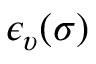<formula> <loc_0><loc_0><loc_500><loc_500>\epsilon _ { \upsilon } ( \sigma )</formula> 